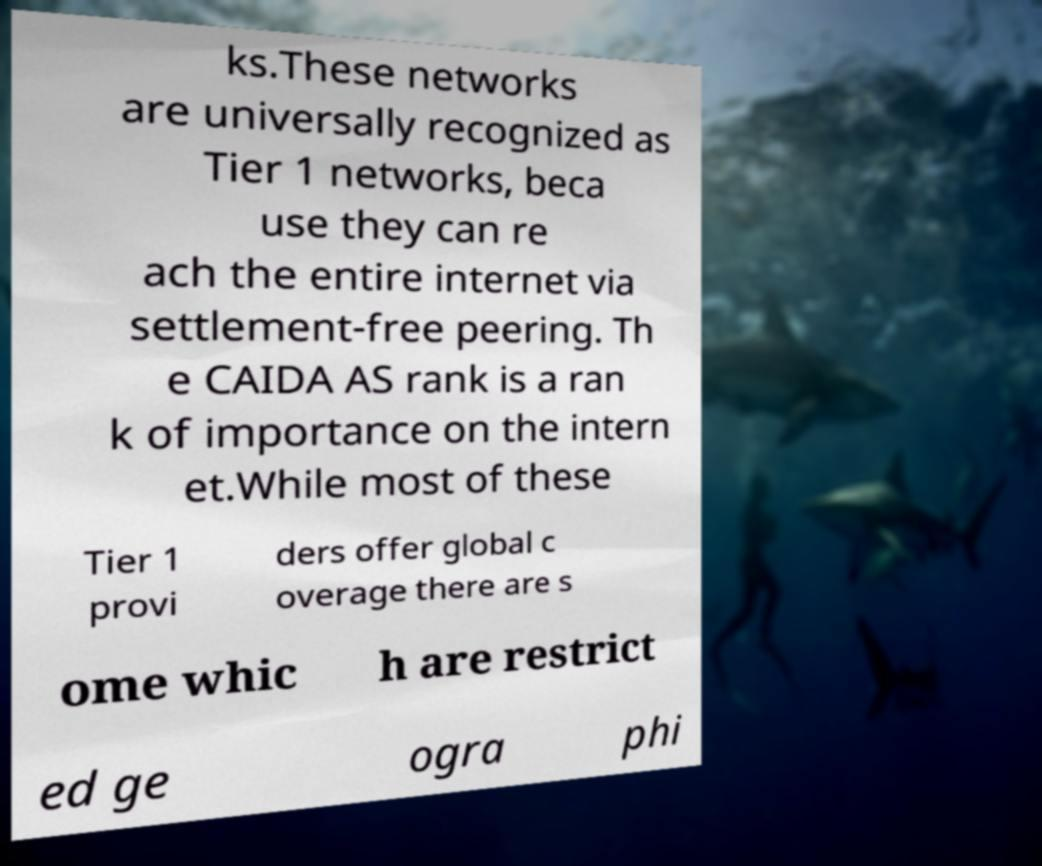Could you extract and type out the text from this image? ks.These networks are universally recognized as Tier 1 networks, beca use they can re ach the entire internet via settlement-free peering. Th e CAIDA AS rank is a ran k of importance on the intern et.While most of these Tier 1 provi ders offer global c overage there are s ome whic h are restrict ed ge ogra phi 